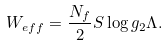<formula> <loc_0><loc_0><loc_500><loc_500>W _ { e f f } = \frac { N _ { f } } { 2 } S \log { g _ { 2 } \Lambda } .</formula> 